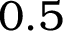Convert formula to latex. <formula><loc_0><loc_0><loc_500><loc_500>0 . 5</formula> 